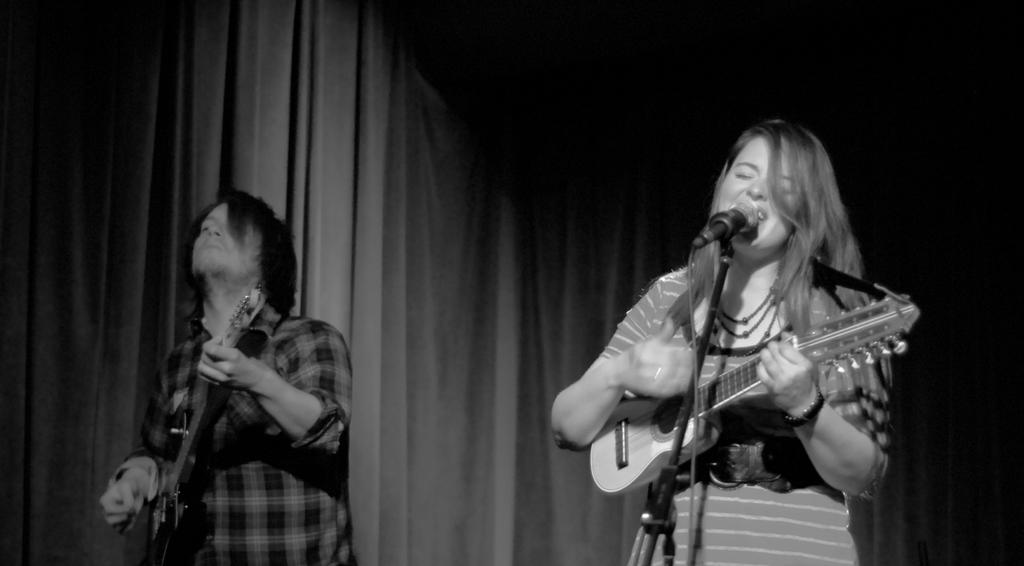How many people are in the image? There are two people in the image. What are the people doing in the image? Both people are holding musical instruments and singing. Can you describe the lady's position in the image? The lady has a microphone in front of her. What can be seen in the background of the image? There is a curtain in the background of the image. How many fingers does the baby have in the image? There is no baby present in the image. What type of room is depicted in the image? The provided facts do not mention the type of room or any room at all, so it cannot be determined from the image. 